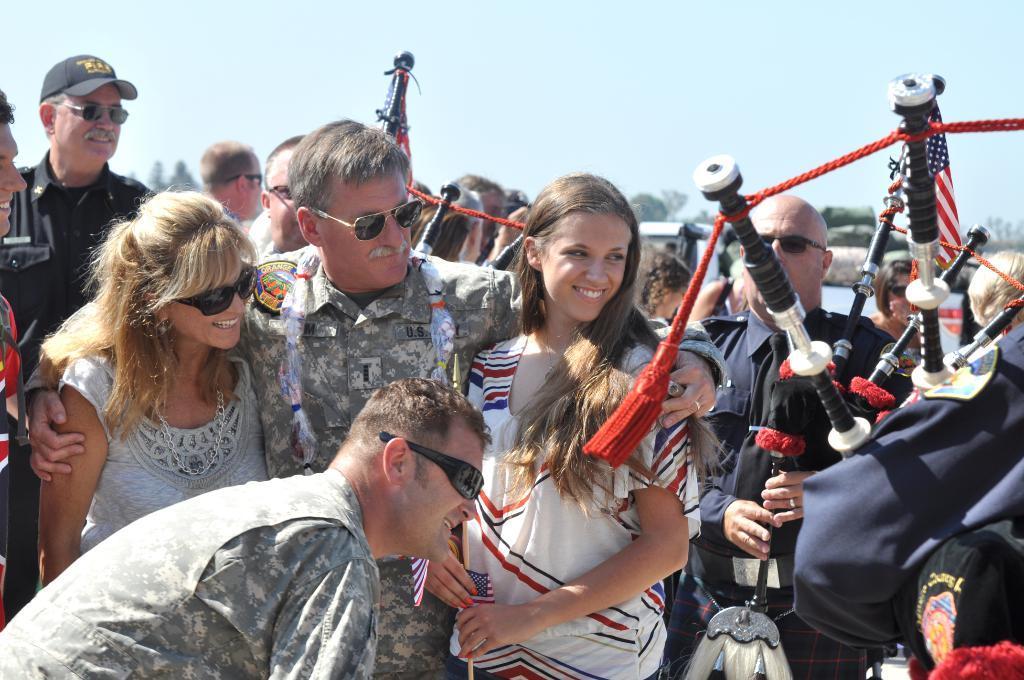Describe this image in one or two sentences. In this image we can see group of people and other objects. In the background there is sky. 